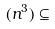<formula> <loc_0><loc_0><loc_500><loc_500>( n ^ { 3 } ) \subseteq</formula> 